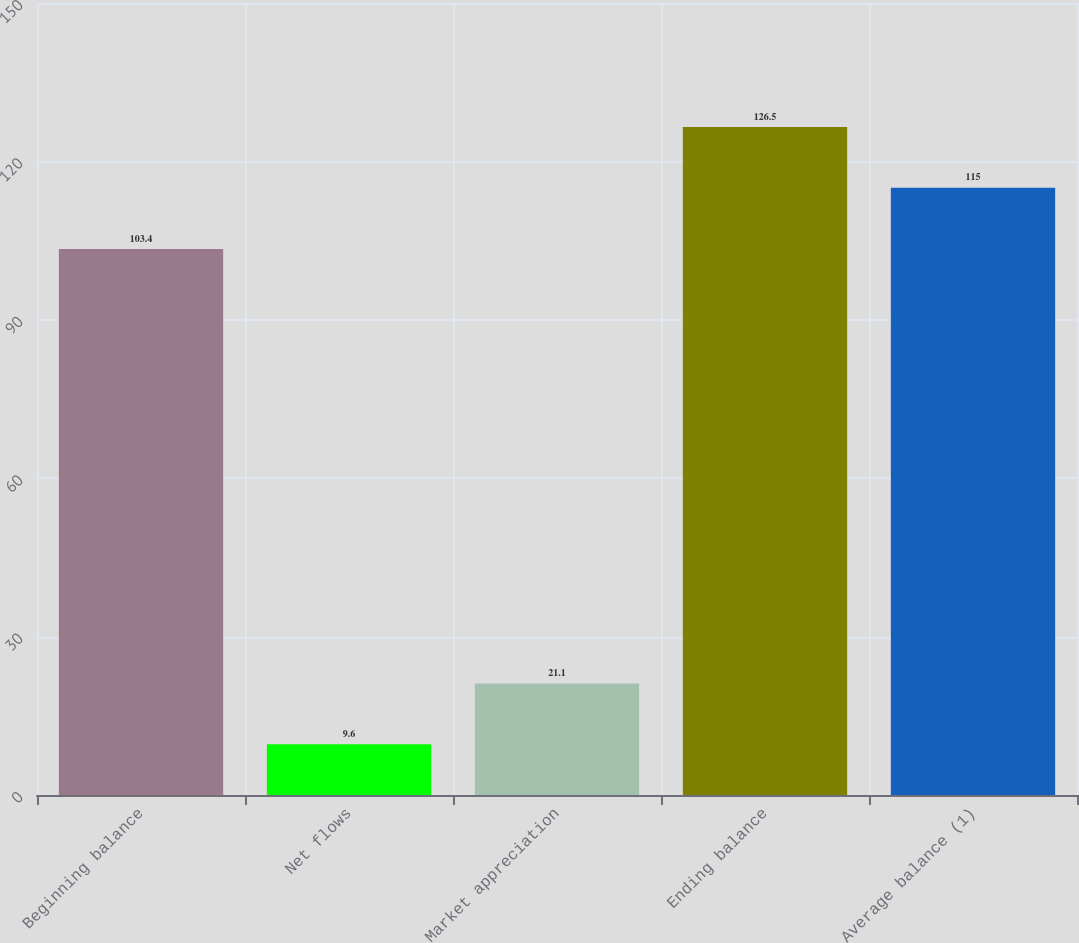Convert chart. <chart><loc_0><loc_0><loc_500><loc_500><bar_chart><fcel>Beginning balance<fcel>Net flows<fcel>Market appreciation<fcel>Ending balance<fcel>Average balance (1)<nl><fcel>103.4<fcel>9.6<fcel>21.1<fcel>126.5<fcel>115<nl></chart> 